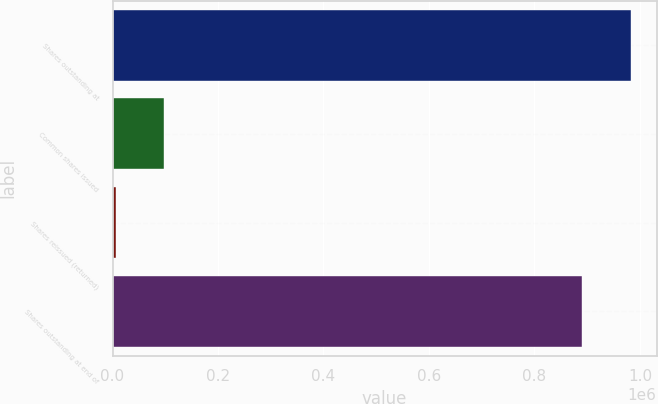Convert chart. <chart><loc_0><loc_0><loc_500><loc_500><bar_chart><fcel>Shares outstanding at<fcel>Common shares issued<fcel>Shares reissued (returned)<fcel>Shares outstanding at end of<nl><fcel>982646<fcel>98475.5<fcel>6554<fcel>890724<nl></chart> 